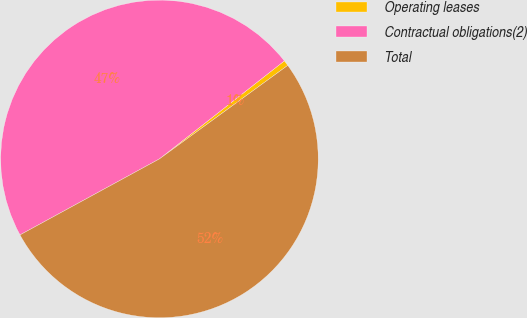<chart> <loc_0><loc_0><loc_500><loc_500><pie_chart><fcel>Operating leases<fcel>Contractual obligations(2)<fcel>Total<nl><fcel>0.57%<fcel>47.35%<fcel>52.08%<nl></chart> 